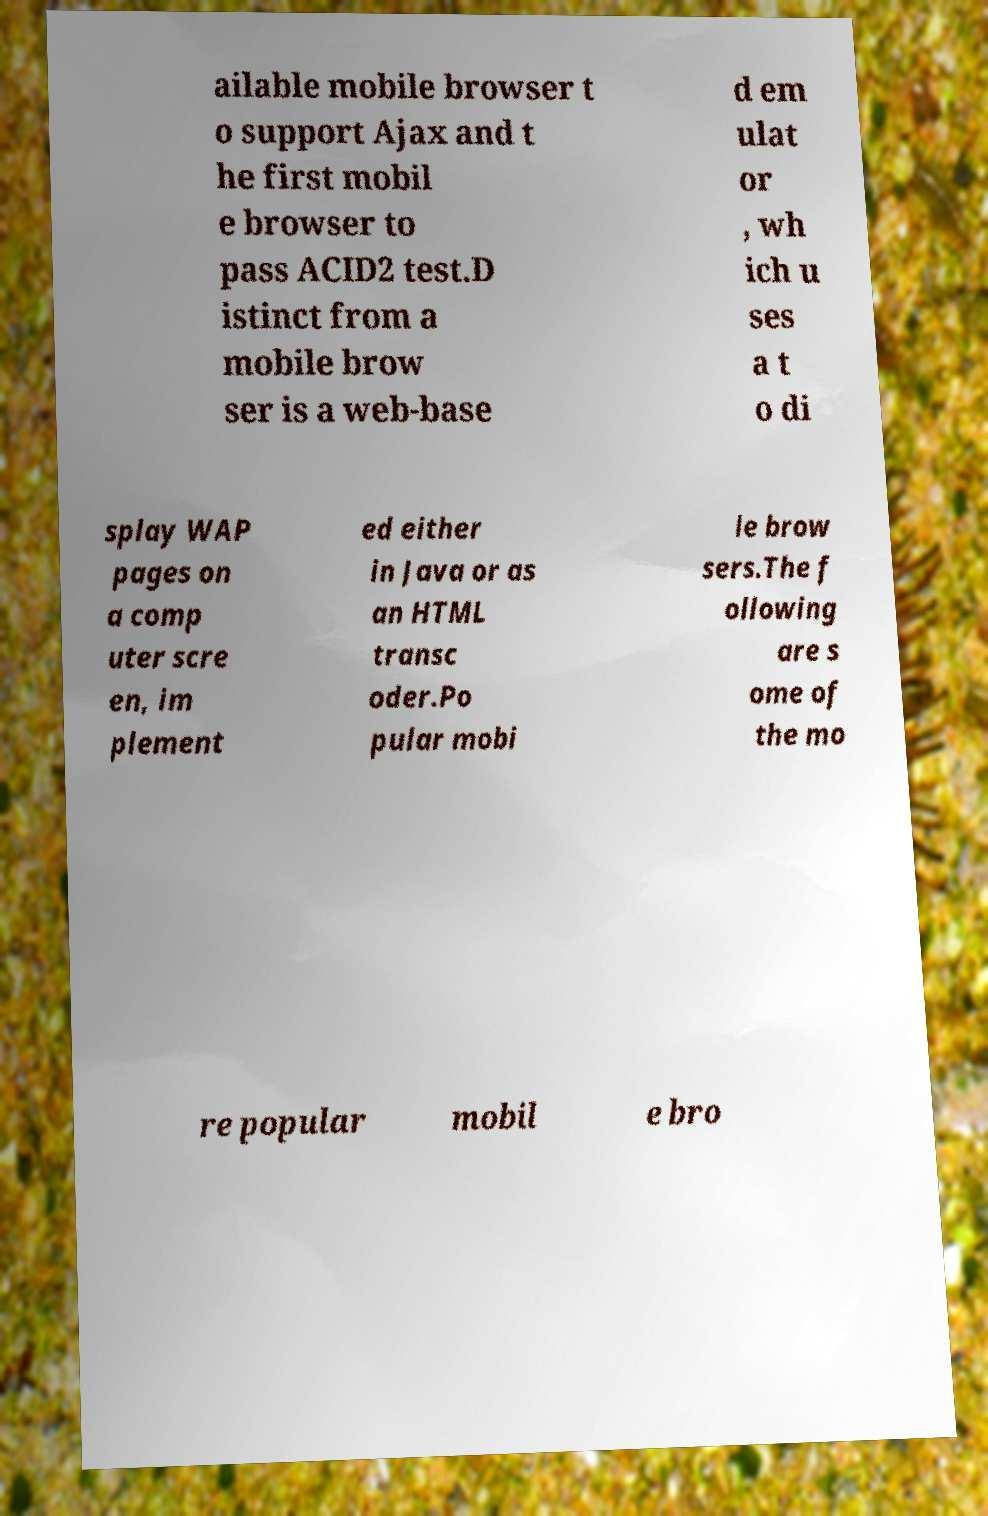Please read and relay the text visible in this image. What does it say? ailable mobile browser t o support Ajax and t he first mobil e browser to pass ACID2 test.D istinct from a mobile brow ser is a web-base d em ulat or , wh ich u ses a t o di splay WAP pages on a comp uter scre en, im plement ed either in Java or as an HTML transc oder.Po pular mobi le brow sers.The f ollowing are s ome of the mo re popular mobil e bro 